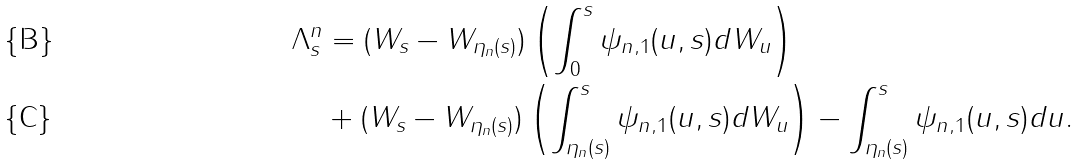<formula> <loc_0><loc_0><loc_500><loc_500>\Lambda ^ { n } _ { s } & = ( W _ { s } - W _ { \eta _ { n } ( s ) } ) \left ( \int _ { 0 } ^ { s } \psi _ { n , 1 } ( u , s ) d W _ { u } \right ) \\ & + ( W _ { s } - W _ { \eta _ { n } ( s ) } ) \left ( \int _ { \eta _ { n } ( s ) } ^ { s } \psi _ { n , 1 } ( u , s ) d W _ { u } \right ) - \int _ { \eta _ { n } ( s ) } ^ { s } \psi _ { n , 1 } ( u , s ) d u .</formula> 